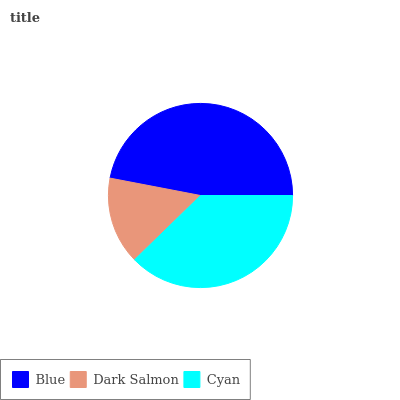Is Dark Salmon the minimum?
Answer yes or no. Yes. Is Blue the maximum?
Answer yes or no. Yes. Is Cyan the minimum?
Answer yes or no. No. Is Cyan the maximum?
Answer yes or no. No. Is Cyan greater than Dark Salmon?
Answer yes or no. Yes. Is Dark Salmon less than Cyan?
Answer yes or no. Yes. Is Dark Salmon greater than Cyan?
Answer yes or no. No. Is Cyan less than Dark Salmon?
Answer yes or no. No. Is Cyan the high median?
Answer yes or no. Yes. Is Cyan the low median?
Answer yes or no. Yes. Is Blue the high median?
Answer yes or no. No. Is Blue the low median?
Answer yes or no. No. 